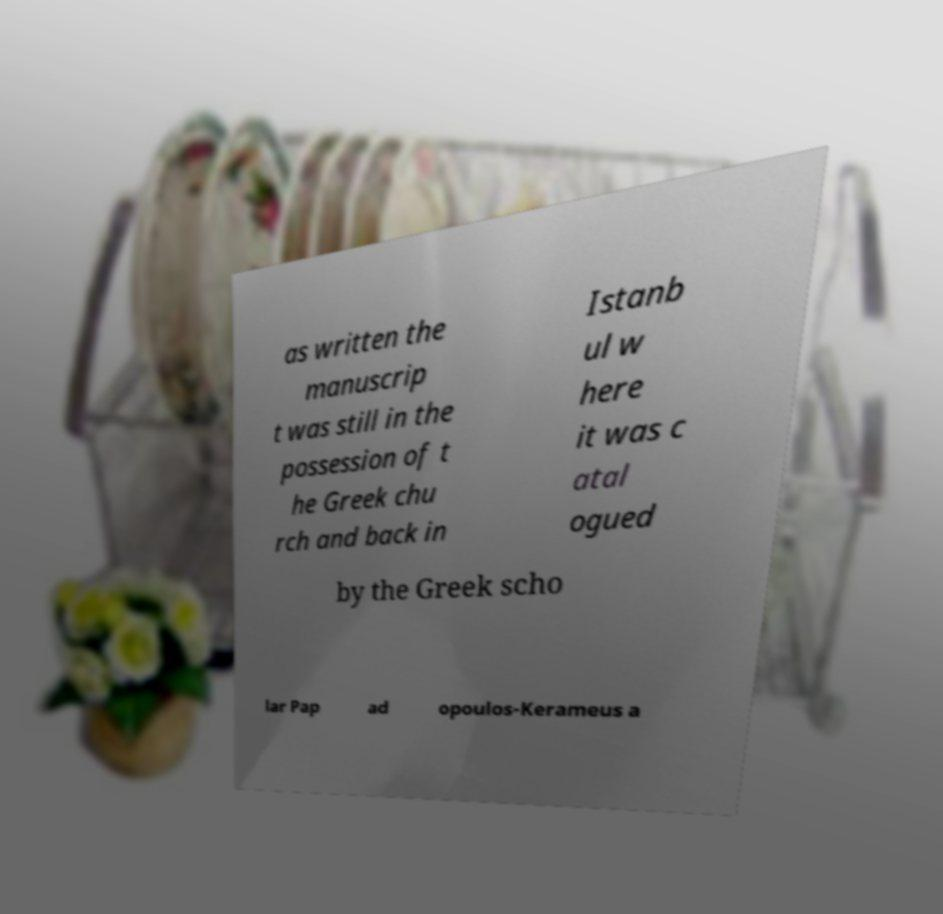Can you read and provide the text displayed in the image?This photo seems to have some interesting text. Can you extract and type it out for me? as written the manuscrip t was still in the possession of t he Greek chu rch and back in Istanb ul w here it was c atal ogued by the Greek scho lar Pap ad opoulos-Kerameus a 